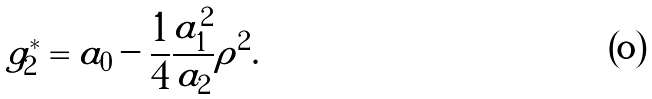Convert formula to latex. <formula><loc_0><loc_0><loc_500><loc_500>g ^ { * } _ { 2 } = a _ { 0 } - \frac { 1 } { 4 } \frac { a _ { 1 } ^ { 2 } } { a _ { 2 } } \rho ^ { 2 } .</formula> 